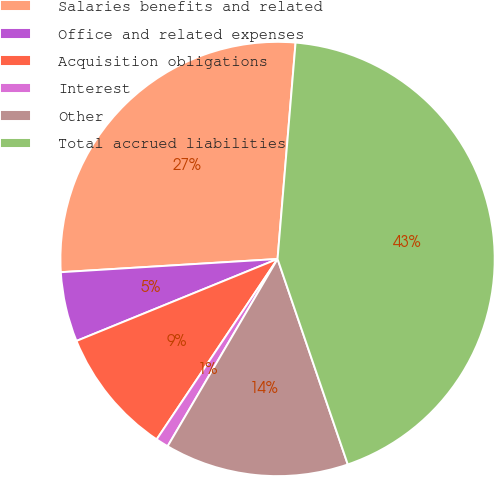Convert chart to OTSL. <chart><loc_0><loc_0><loc_500><loc_500><pie_chart><fcel>Salaries benefits and related<fcel>Office and related expenses<fcel>Acquisition obligations<fcel>Interest<fcel>Other<fcel>Total accrued liabilities<nl><fcel>27.29%<fcel>5.19%<fcel>9.44%<fcel>0.95%<fcel>13.69%<fcel>43.43%<nl></chart> 